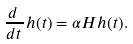Convert formula to latex. <formula><loc_0><loc_0><loc_500><loc_500>\frac { d \, } { d t \, } h ( t ) = \alpha H h ( t ) .</formula> 